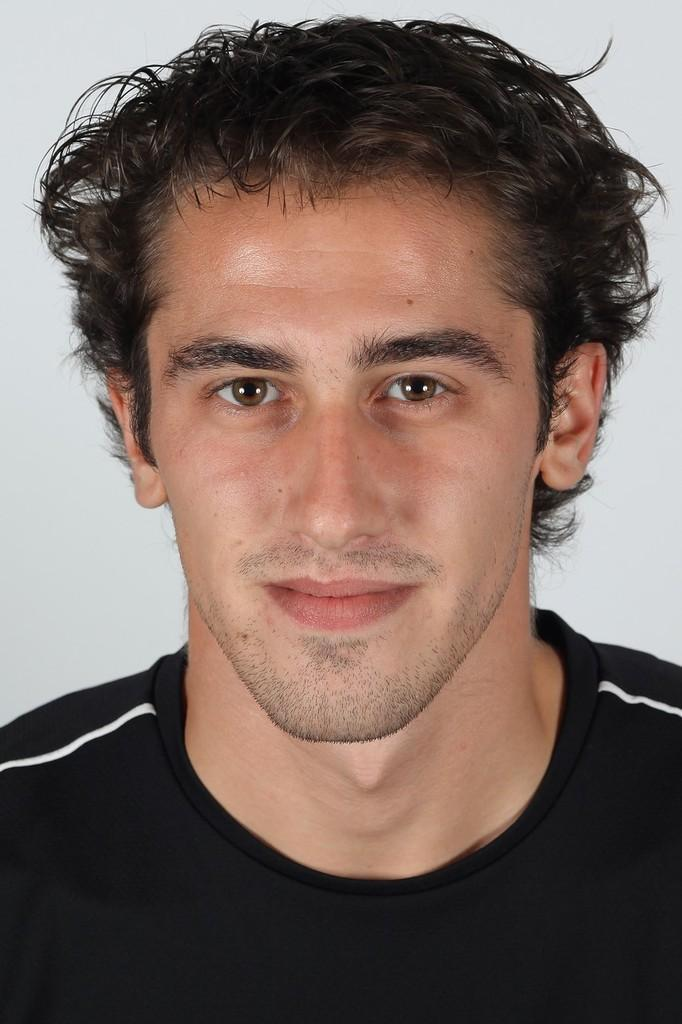Who is present in the image? There is a man in the image. What is the man wearing in the image? The man is wearing a t-shirt in the image. What can be seen behind the man in the image? There is a white background in the image. How many drawers are visible in the image? There are no drawers present in the image. What word is written on the man's t-shirt in the image? There is no word visible on the man's t-shirt in the image. 